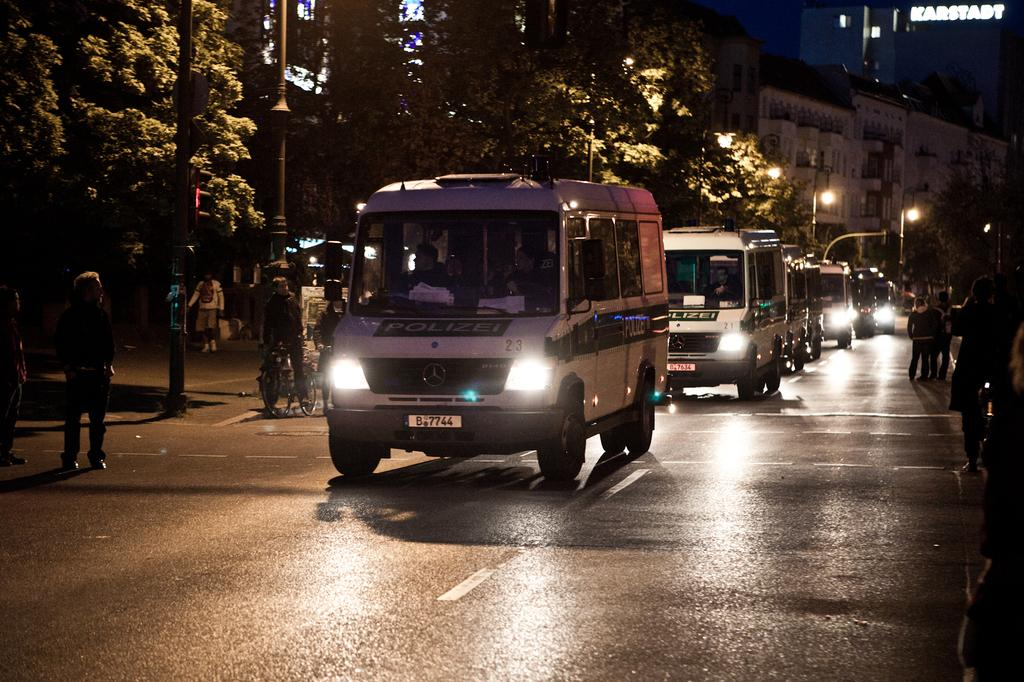What can be seen in the image that moves or travels? There are vehicles in the image that move or travel. What else can be seen in the image besides vehicles? There are people standing on the road in the image. What is located on the left side of the image? There are trees, buildings, and street lights on the left side of the image. What is the income of the queen in the image? There is no queen present in the image, so it is not possible to determine her income. 